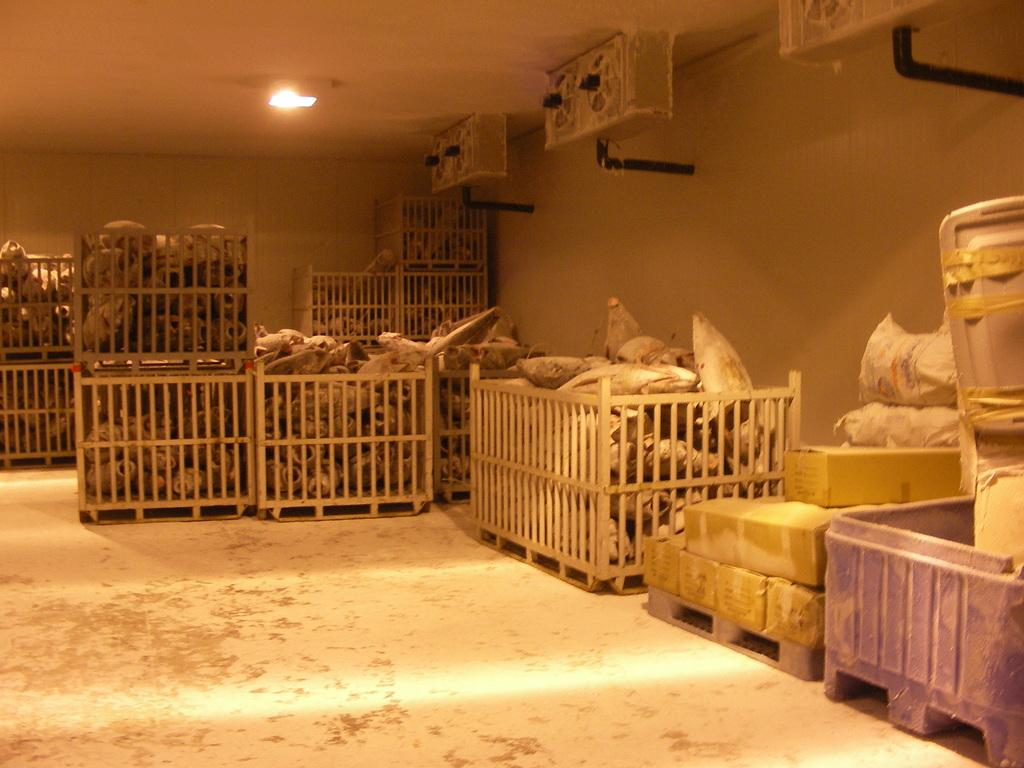What type of containers are visible in the image? The containers are cardboard boxes. What might be inside the cardboard boxes? We cannot determine what is inside the cardboard boxes from the image alone. Can you describe the source of light in the image? Unfortunately, the facts provided do not give enough information to describe the source of light in the image. How many clocks are visible in the image? There are no clocks present in the image. What type of request is being made in the image? There is no request being made in the image. 